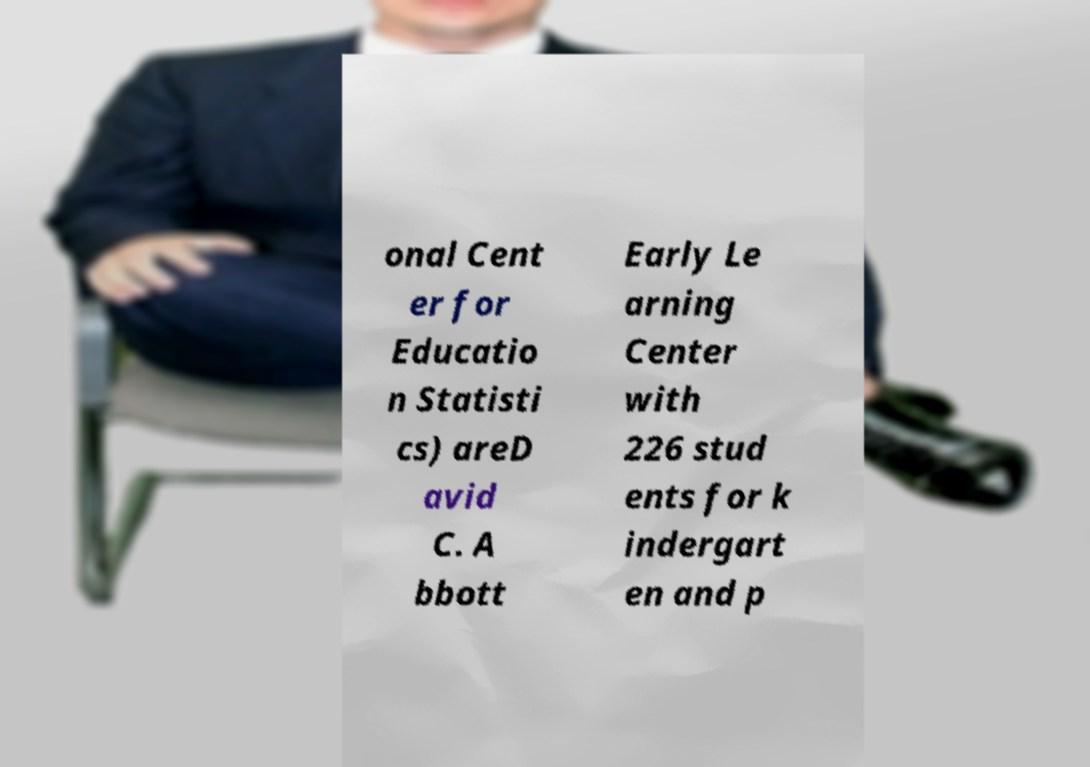What messages or text are displayed in this image? I need them in a readable, typed format. onal Cent er for Educatio n Statisti cs) areD avid C. A bbott Early Le arning Center with 226 stud ents for k indergart en and p 